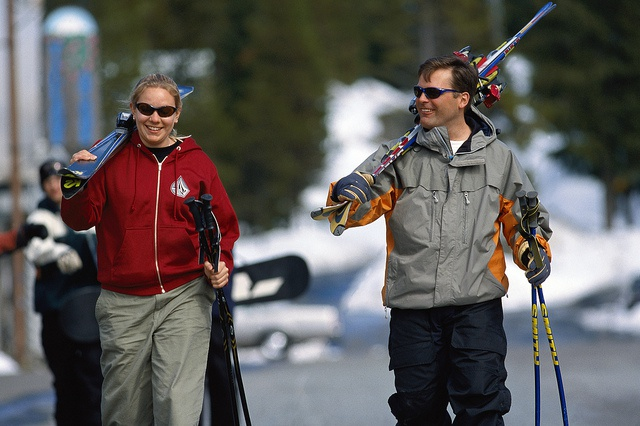Describe the objects in this image and their specific colors. I can see people in darkgray, black, gray, and maroon tones, people in darkgray, maroon, black, and gray tones, people in darkgray, black, gray, and lightgray tones, car in darkgray, lightgray, and gray tones, and snowboard in darkgray, black, lightgray, and gray tones in this image. 